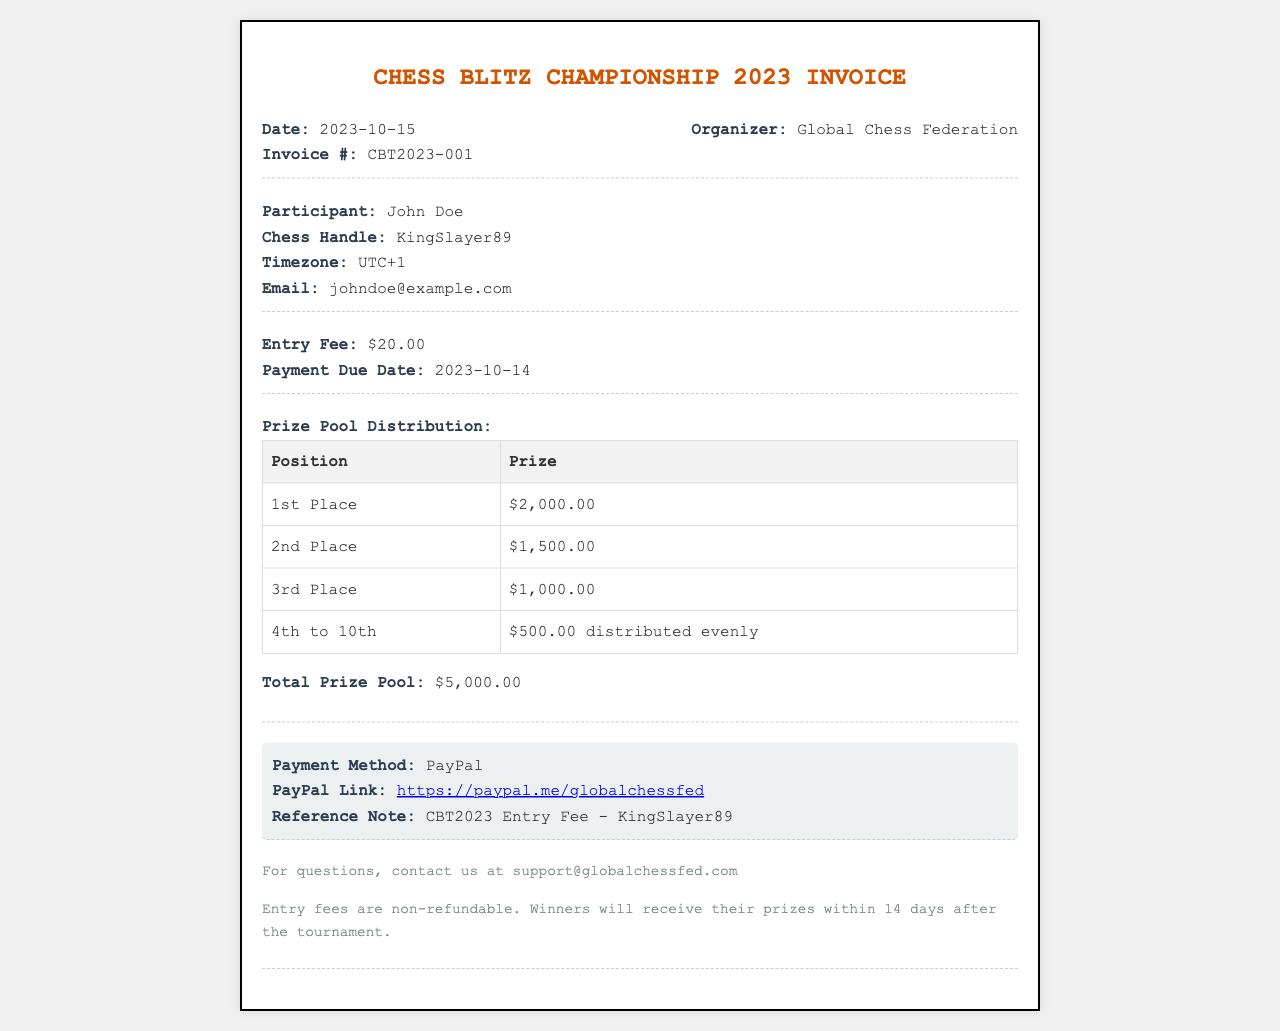What is the date of the invoice? The date of the invoice is prominently displayed in the header section and is listed as 2023-10-15.
Answer: 2023-10-15 What is the entry fee for the tournament? The entry fee for participating in the tournament can be found under the fees section, listed as $20.00.
Answer: $20.00 Who is the participant? The participant's name is indicated in the participant section, which lists John Doe as the participant.
Answer: John Doe What is the total prize pool? The total prize pool is specified at the end of the prize pool distribution section, totaling $5,000.00.
Answer: $5,000.00 What prize does the 1st place winner receive? The prize for the 1st place winner is detailed in the prize pool distribution table, which states it is $2,000.00.
Answer: $2,000.00 When is the payment due date? The payment due date is noted in the fees section of the invoice and is listed as 2023-10-14.
Answer: 2023-10-14 What is the payment method stated in the invoice? The payment method is mentioned in the payment section of the invoice, which specifies PayPal as the method.
Answer: PayPal What is the PayPal link provided for payment? The PayPal link is included in the payment section, which can be directly copied or visited for payment purposes.
Answer: https://paypal.me/globalchessfed How many days after the tournament will prizes be awarded? The footer section mentions that winners will receive their prizes within 14 days after the tournament.
Answer: 14 days 